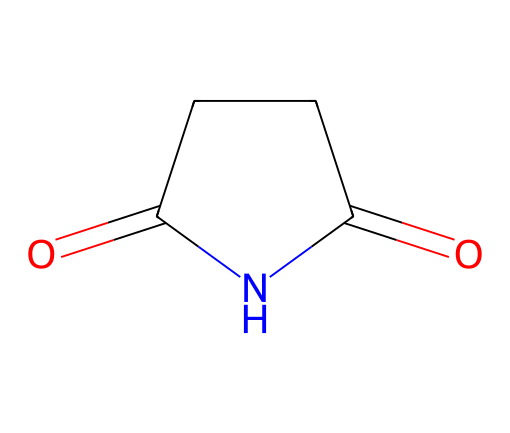How many carbon atoms are in succinimide? The SMILES notation indicates the structure of the compound, where "C" represents carbon atoms. By analyzing the structure, I can count a total of 4 carbon atoms connected in a ring formation.
Answer: 4 What is the main functional group in succinimide? In the structure of succinimide, the presence of the carbonyl group (=O) adjacent to the nitrogen atom suggests it contains an imide functional group because it connects two carbonyl groups with a nitrogen atom.
Answer: imide How many nitrogen atoms are present in succinimide? Looking at the SMILES representation, there is one "N" indicating the presence of a single nitrogen atom in the overall structure of succinimide.
Answer: 1 What type of bonding is most prevalent in succinimide? The structure shows multiple carbon-carbon (C-C) and carbon-nitrogen (C-N) single bonds, as well as carbon-oxygen (C=O) double bonds, identifying covalent bonding as the predominant type in this compound.
Answer: covalent Is succinimide a saturated or unsaturated compound? By inspecting the structure, since there are double bonds present (specifically the carbonyl groups), it indicates some level of unsaturation, as saturated compounds contain only single bonds.
Answer: unsaturated What is the molecular formula of succinimide? Analyzing the structure and counting each element, reducing to the simplest ratio of atoms leads to the molecular formula, which is determined as C4H5NO2.
Answer: C4H5NO2 